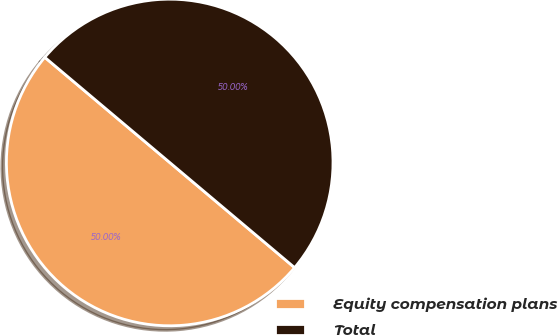<chart> <loc_0><loc_0><loc_500><loc_500><pie_chart><fcel>Equity compensation plans<fcel>Total<nl><fcel>50.0%<fcel>50.0%<nl></chart> 